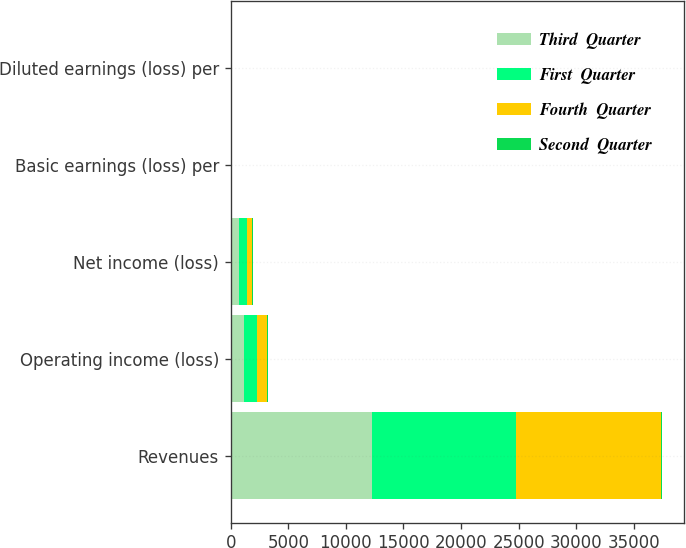<chart> <loc_0><loc_0><loc_500><loc_500><stacked_bar_chart><ecel><fcel>Revenues<fcel>Operating income (loss)<fcel>Net income (loss)<fcel>Basic earnings (loss) per<fcel>Diluted earnings (loss) per<nl><fcel>Third  Quarter<fcel>12279<fcel>1144<fcel>692<fcel>2.45<fcel>2.42<nl><fcel>First  Quarter<fcel>12453<fcel>1137<fcel>691<fcel>2.47<fcel>2.44<nl><fcel>Fourth  Quarter<fcel>12654<fcel>864<fcel>507<fcel>1.86<fcel>1.84<nl><fcel>Second  Quarter<fcel>70<fcel>68<fcel>70<fcel>0.26<fcel>0.26<nl></chart> 